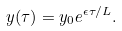<formula> <loc_0><loc_0><loc_500><loc_500>y ( \tau ) = y _ { 0 } e ^ { \epsilon \tau / L } .</formula> 